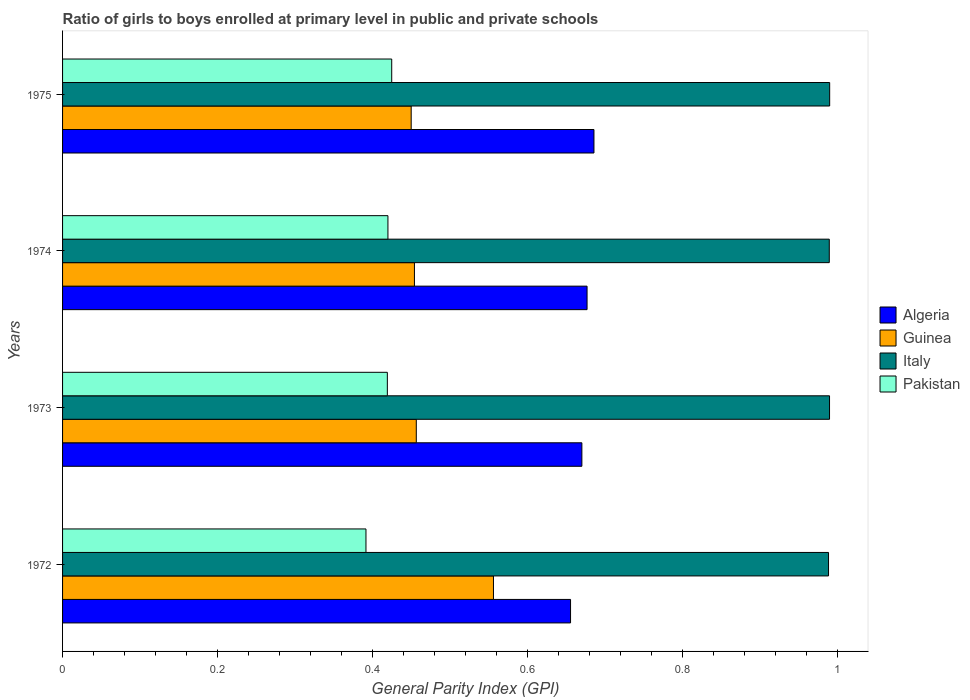What is the label of the 1st group of bars from the top?
Your answer should be compact. 1975. What is the general parity index in Guinea in 1975?
Your answer should be compact. 0.45. Across all years, what is the maximum general parity index in Pakistan?
Offer a very short reply. 0.42. Across all years, what is the minimum general parity index in Algeria?
Make the answer very short. 0.66. In which year was the general parity index in Pakistan maximum?
Give a very brief answer. 1975. What is the total general parity index in Italy in the graph?
Keep it short and to the point. 3.96. What is the difference between the general parity index in Pakistan in 1972 and that in 1974?
Offer a very short reply. -0.03. What is the difference between the general parity index in Guinea in 1973 and the general parity index in Italy in 1972?
Provide a short and direct response. -0.53. What is the average general parity index in Pakistan per year?
Provide a short and direct response. 0.41. In the year 1975, what is the difference between the general parity index in Guinea and general parity index in Algeria?
Ensure brevity in your answer.  -0.24. In how many years, is the general parity index in Algeria greater than 0.04 ?
Keep it short and to the point. 4. What is the ratio of the general parity index in Pakistan in 1973 to that in 1974?
Offer a very short reply. 1. Is the general parity index in Italy in 1973 less than that in 1975?
Keep it short and to the point. Yes. What is the difference between the highest and the second highest general parity index in Italy?
Provide a succinct answer. 0. What is the difference between the highest and the lowest general parity index in Pakistan?
Give a very brief answer. 0.03. In how many years, is the general parity index in Algeria greater than the average general parity index in Algeria taken over all years?
Your answer should be very brief. 2. Is the sum of the general parity index in Guinea in 1973 and 1975 greater than the maximum general parity index in Algeria across all years?
Your answer should be compact. Yes. Is it the case that in every year, the sum of the general parity index in Pakistan and general parity index in Italy is greater than the general parity index in Guinea?
Provide a succinct answer. Yes. What is the difference between two consecutive major ticks on the X-axis?
Your response must be concise. 0.2. Where does the legend appear in the graph?
Your answer should be compact. Center right. How many legend labels are there?
Provide a short and direct response. 4. What is the title of the graph?
Your answer should be very brief. Ratio of girls to boys enrolled at primary level in public and private schools. What is the label or title of the X-axis?
Your answer should be compact. General Parity Index (GPI). What is the General Parity Index (GPI) of Algeria in 1972?
Provide a short and direct response. 0.66. What is the General Parity Index (GPI) in Guinea in 1972?
Your response must be concise. 0.56. What is the General Parity Index (GPI) of Italy in 1972?
Give a very brief answer. 0.99. What is the General Parity Index (GPI) in Pakistan in 1972?
Provide a succinct answer. 0.39. What is the General Parity Index (GPI) of Algeria in 1973?
Offer a terse response. 0.67. What is the General Parity Index (GPI) in Guinea in 1973?
Your answer should be very brief. 0.46. What is the General Parity Index (GPI) in Italy in 1973?
Your response must be concise. 0.99. What is the General Parity Index (GPI) of Pakistan in 1973?
Give a very brief answer. 0.42. What is the General Parity Index (GPI) of Algeria in 1974?
Ensure brevity in your answer.  0.68. What is the General Parity Index (GPI) in Guinea in 1974?
Offer a very short reply. 0.45. What is the General Parity Index (GPI) of Italy in 1974?
Provide a succinct answer. 0.99. What is the General Parity Index (GPI) of Pakistan in 1974?
Ensure brevity in your answer.  0.42. What is the General Parity Index (GPI) in Algeria in 1975?
Offer a terse response. 0.69. What is the General Parity Index (GPI) in Guinea in 1975?
Your response must be concise. 0.45. What is the General Parity Index (GPI) of Italy in 1975?
Give a very brief answer. 0.99. What is the General Parity Index (GPI) in Pakistan in 1975?
Keep it short and to the point. 0.42. Across all years, what is the maximum General Parity Index (GPI) in Algeria?
Your answer should be compact. 0.69. Across all years, what is the maximum General Parity Index (GPI) in Guinea?
Provide a short and direct response. 0.56. Across all years, what is the maximum General Parity Index (GPI) in Italy?
Make the answer very short. 0.99. Across all years, what is the maximum General Parity Index (GPI) of Pakistan?
Make the answer very short. 0.42. Across all years, what is the minimum General Parity Index (GPI) in Algeria?
Offer a terse response. 0.66. Across all years, what is the minimum General Parity Index (GPI) in Guinea?
Your answer should be compact. 0.45. Across all years, what is the minimum General Parity Index (GPI) of Italy?
Provide a succinct answer. 0.99. Across all years, what is the minimum General Parity Index (GPI) in Pakistan?
Make the answer very short. 0.39. What is the total General Parity Index (GPI) in Algeria in the graph?
Offer a terse response. 2.69. What is the total General Parity Index (GPI) of Guinea in the graph?
Your answer should be very brief. 1.92. What is the total General Parity Index (GPI) of Italy in the graph?
Give a very brief answer. 3.96. What is the total General Parity Index (GPI) of Pakistan in the graph?
Make the answer very short. 1.65. What is the difference between the General Parity Index (GPI) in Algeria in 1972 and that in 1973?
Your answer should be very brief. -0.01. What is the difference between the General Parity Index (GPI) of Guinea in 1972 and that in 1973?
Provide a succinct answer. 0.1. What is the difference between the General Parity Index (GPI) in Italy in 1972 and that in 1973?
Provide a succinct answer. -0. What is the difference between the General Parity Index (GPI) of Pakistan in 1972 and that in 1973?
Provide a succinct answer. -0.03. What is the difference between the General Parity Index (GPI) in Algeria in 1972 and that in 1974?
Your answer should be very brief. -0.02. What is the difference between the General Parity Index (GPI) of Guinea in 1972 and that in 1974?
Your answer should be compact. 0.1. What is the difference between the General Parity Index (GPI) in Italy in 1972 and that in 1974?
Your answer should be very brief. -0. What is the difference between the General Parity Index (GPI) in Pakistan in 1972 and that in 1974?
Offer a terse response. -0.03. What is the difference between the General Parity Index (GPI) in Algeria in 1972 and that in 1975?
Your answer should be compact. -0.03. What is the difference between the General Parity Index (GPI) of Guinea in 1972 and that in 1975?
Give a very brief answer. 0.11. What is the difference between the General Parity Index (GPI) in Italy in 1972 and that in 1975?
Keep it short and to the point. -0. What is the difference between the General Parity Index (GPI) in Pakistan in 1972 and that in 1975?
Give a very brief answer. -0.03. What is the difference between the General Parity Index (GPI) in Algeria in 1973 and that in 1974?
Ensure brevity in your answer.  -0.01. What is the difference between the General Parity Index (GPI) in Guinea in 1973 and that in 1974?
Offer a terse response. 0. What is the difference between the General Parity Index (GPI) of Italy in 1973 and that in 1974?
Your answer should be very brief. 0. What is the difference between the General Parity Index (GPI) in Pakistan in 1973 and that in 1974?
Offer a very short reply. -0. What is the difference between the General Parity Index (GPI) of Algeria in 1973 and that in 1975?
Ensure brevity in your answer.  -0.02. What is the difference between the General Parity Index (GPI) of Guinea in 1973 and that in 1975?
Your answer should be very brief. 0.01. What is the difference between the General Parity Index (GPI) in Italy in 1973 and that in 1975?
Give a very brief answer. -0. What is the difference between the General Parity Index (GPI) in Pakistan in 1973 and that in 1975?
Keep it short and to the point. -0.01. What is the difference between the General Parity Index (GPI) in Algeria in 1974 and that in 1975?
Ensure brevity in your answer.  -0.01. What is the difference between the General Parity Index (GPI) of Guinea in 1974 and that in 1975?
Your response must be concise. 0. What is the difference between the General Parity Index (GPI) in Italy in 1974 and that in 1975?
Provide a short and direct response. -0. What is the difference between the General Parity Index (GPI) of Pakistan in 1974 and that in 1975?
Give a very brief answer. -0. What is the difference between the General Parity Index (GPI) in Algeria in 1972 and the General Parity Index (GPI) in Guinea in 1973?
Offer a very short reply. 0.2. What is the difference between the General Parity Index (GPI) of Algeria in 1972 and the General Parity Index (GPI) of Italy in 1973?
Give a very brief answer. -0.33. What is the difference between the General Parity Index (GPI) of Algeria in 1972 and the General Parity Index (GPI) of Pakistan in 1973?
Ensure brevity in your answer.  0.24. What is the difference between the General Parity Index (GPI) of Guinea in 1972 and the General Parity Index (GPI) of Italy in 1973?
Make the answer very short. -0.43. What is the difference between the General Parity Index (GPI) of Guinea in 1972 and the General Parity Index (GPI) of Pakistan in 1973?
Your response must be concise. 0.14. What is the difference between the General Parity Index (GPI) in Italy in 1972 and the General Parity Index (GPI) in Pakistan in 1973?
Ensure brevity in your answer.  0.57. What is the difference between the General Parity Index (GPI) in Algeria in 1972 and the General Parity Index (GPI) in Guinea in 1974?
Make the answer very short. 0.2. What is the difference between the General Parity Index (GPI) in Algeria in 1972 and the General Parity Index (GPI) in Italy in 1974?
Offer a very short reply. -0.33. What is the difference between the General Parity Index (GPI) in Algeria in 1972 and the General Parity Index (GPI) in Pakistan in 1974?
Your answer should be very brief. 0.24. What is the difference between the General Parity Index (GPI) of Guinea in 1972 and the General Parity Index (GPI) of Italy in 1974?
Your answer should be compact. -0.43. What is the difference between the General Parity Index (GPI) in Guinea in 1972 and the General Parity Index (GPI) in Pakistan in 1974?
Keep it short and to the point. 0.14. What is the difference between the General Parity Index (GPI) of Italy in 1972 and the General Parity Index (GPI) of Pakistan in 1974?
Ensure brevity in your answer.  0.57. What is the difference between the General Parity Index (GPI) of Algeria in 1972 and the General Parity Index (GPI) of Guinea in 1975?
Give a very brief answer. 0.21. What is the difference between the General Parity Index (GPI) in Algeria in 1972 and the General Parity Index (GPI) in Italy in 1975?
Provide a short and direct response. -0.33. What is the difference between the General Parity Index (GPI) of Algeria in 1972 and the General Parity Index (GPI) of Pakistan in 1975?
Offer a very short reply. 0.23. What is the difference between the General Parity Index (GPI) in Guinea in 1972 and the General Parity Index (GPI) in Italy in 1975?
Offer a very short reply. -0.43. What is the difference between the General Parity Index (GPI) in Guinea in 1972 and the General Parity Index (GPI) in Pakistan in 1975?
Offer a very short reply. 0.13. What is the difference between the General Parity Index (GPI) of Italy in 1972 and the General Parity Index (GPI) of Pakistan in 1975?
Offer a terse response. 0.56. What is the difference between the General Parity Index (GPI) of Algeria in 1973 and the General Parity Index (GPI) of Guinea in 1974?
Offer a very short reply. 0.22. What is the difference between the General Parity Index (GPI) in Algeria in 1973 and the General Parity Index (GPI) in Italy in 1974?
Your answer should be compact. -0.32. What is the difference between the General Parity Index (GPI) in Algeria in 1973 and the General Parity Index (GPI) in Pakistan in 1974?
Offer a terse response. 0.25. What is the difference between the General Parity Index (GPI) of Guinea in 1973 and the General Parity Index (GPI) of Italy in 1974?
Provide a succinct answer. -0.53. What is the difference between the General Parity Index (GPI) in Guinea in 1973 and the General Parity Index (GPI) in Pakistan in 1974?
Your answer should be compact. 0.04. What is the difference between the General Parity Index (GPI) in Italy in 1973 and the General Parity Index (GPI) in Pakistan in 1974?
Your answer should be very brief. 0.57. What is the difference between the General Parity Index (GPI) in Algeria in 1973 and the General Parity Index (GPI) in Guinea in 1975?
Keep it short and to the point. 0.22. What is the difference between the General Parity Index (GPI) in Algeria in 1973 and the General Parity Index (GPI) in Italy in 1975?
Your response must be concise. -0.32. What is the difference between the General Parity Index (GPI) in Algeria in 1973 and the General Parity Index (GPI) in Pakistan in 1975?
Offer a terse response. 0.25. What is the difference between the General Parity Index (GPI) in Guinea in 1973 and the General Parity Index (GPI) in Italy in 1975?
Your answer should be compact. -0.53. What is the difference between the General Parity Index (GPI) of Guinea in 1973 and the General Parity Index (GPI) of Pakistan in 1975?
Offer a terse response. 0.03. What is the difference between the General Parity Index (GPI) of Italy in 1973 and the General Parity Index (GPI) of Pakistan in 1975?
Ensure brevity in your answer.  0.56. What is the difference between the General Parity Index (GPI) in Algeria in 1974 and the General Parity Index (GPI) in Guinea in 1975?
Make the answer very short. 0.23. What is the difference between the General Parity Index (GPI) of Algeria in 1974 and the General Parity Index (GPI) of Italy in 1975?
Provide a short and direct response. -0.31. What is the difference between the General Parity Index (GPI) of Algeria in 1974 and the General Parity Index (GPI) of Pakistan in 1975?
Provide a succinct answer. 0.25. What is the difference between the General Parity Index (GPI) of Guinea in 1974 and the General Parity Index (GPI) of Italy in 1975?
Give a very brief answer. -0.54. What is the difference between the General Parity Index (GPI) in Guinea in 1974 and the General Parity Index (GPI) in Pakistan in 1975?
Keep it short and to the point. 0.03. What is the difference between the General Parity Index (GPI) of Italy in 1974 and the General Parity Index (GPI) of Pakistan in 1975?
Give a very brief answer. 0.56. What is the average General Parity Index (GPI) in Algeria per year?
Offer a terse response. 0.67. What is the average General Parity Index (GPI) in Guinea per year?
Offer a terse response. 0.48. What is the average General Parity Index (GPI) of Italy per year?
Offer a terse response. 0.99. What is the average General Parity Index (GPI) of Pakistan per year?
Make the answer very short. 0.41. In the year 1972, what is the difference between the General Parity Index (GPI) in Algeria and General Parity Index (GPI) in Guinea?
Provide a short and direct response. 0.1. In the year 1972, what is the difference between the General Parity Index (GPI) in Algeria and General Parity Index (GPI) in Italy?
Give a very brief answer. -0.33. In the year 1972, what is the difference between the General Parity Index (GPI) in Algeria and General Parity Index (GPI) in Pakistan?
Provide a succinct answer. 0.26. In the year 1972, what is the difference between the General Parity Index (GPI) of Guinea and General Parity Index (GPI) of Italy?
Keep it short and to the point. -0.43. In the year 1972, what is the difference between the General Parity Index (GPI) in Guinea and General Parity Index (GPI) in Pakistan?
Make the answer very short. 0.16. In the year 1972, what is the difference between the General Parity Index (GPI) of Italy and General Parity Index (GPI) of Pakistan?
Give a very brief answer. 0.6. In the year 1973, what is the difference between the General Parity Index (GPI) of Algeria and General Parity Index (GPI) of Guinea?
Provide a succinct answer. 0.21. In the year 1973, what is the difference between the General Parity Index (GPI) of Algeria and General Parity Index (GPI) of Italy?
Provide a short and direct response. -0.32. In the year 1973, what is the difference between the General Parity Index (GPI) in Algeria and General Parity Index (GPI) in Pakistan?
Make the answer very short. 0.25. In the year 1973, what is the difference between the General Parity Index (GPI) of Guinea and General Parity Index (GPI) of Italy?
Make the answer very short. -0.53. In the year 1973, what is the difference between the General Parity Index (GPI) in Guinea and General Parity Index (GPI) in Pakistan?
Offer a terse response. 0.04. In the year 1973, what is the difference between the General Parity Index (GPI) in Italy and General Parity Index (GPI) in Pakistan?
Make the answer very short. 0.57. In the year 1974, what is the difference between the General Parity Index (GPI) in Algeria and General Parity Index (GPI) in Guinea?
Ensure brevity in your answer.  0.22. In the year 1974, what is the difference between the General Parity Index (GPI) of Algeria and General Parity Index (GPI) of Italy?
Make the answer very short. -0.31. In the year 1974, what is the difference between the General Parity Index (GPI) of Algeria and General Parity Index (GPI) of Pakistan?
Your response must be concise. 0.26. In the year 1974, what is the difference between the General Parity Index (GPI) of Guinea and General Parity Index (GPI) of Italy?
Your answer should be very brief. -0.54. In the year 1974, what is the difference between the General Parity Index (GPI) of Guinea and General Parity Index (GPI) of Pakistan?
Offer a terse response. 0.03. In the year 1974, what is the difference between the General Parity Index (GPI) of Italy and General Parity Index (GPI) of Pakistan?
Keep it short and to the point. 0.57. In the year 1975, what is the difference between the General Parity Index (GPI) in Algeria and General Parity Index (GPI) in Guinea?
Provide a succinct answer. 0.24. In the year 1975, what is the difference between the General Parity Index (GPI) of Algeria and General Parity Index (GPI) of Italy?
Ensure brevity in your answer.  -0.3. In the year 1975, what is the difference between the General Parity Index (GPI) of Algeria and General Parity Index (GPI) of Pakistan?
Your answer should be compact. 0.26. In the year 1975, what is the difference between the General Parity Index (GPI) of Guinea and General Parity Index (GPI) of Italy?
Ensure brevity in your answer.  -0.54. In the year 1975, what is the difference between the General Parity Index (GPI) in Guinea and General Parity Index (GPI) in Pakistan?
Provide a succinct answer. 0.03. In the year 1975, what is the difference between the General Parity Index (GPI) in Italy and General Parity Index (GPI) in Pakistan?
Provide a succinct answer. 0.56. What is the ratio of the General Parity Index (GPI) of Algeria in 1972 to that in 1973?
Ensure brevity in your answer.  0.98. What is the ratio of the General Parity Index (GPI) of Guinea in 1972 to that in 1973?
Ensure brevity in your answer.  1.22. What is the ratio of the General Parity Index (GPI) of Pakistan in 1972 to that in 1973?
Provide a succinct answer. 0.93. What is the ratio of the General Parity Index (GPI) in Algeria in 1972 to that in 1974?
Provide a short and direct response. 0.97. What is the ratio of the General Parity Index (GPI) of Guinea in 1972 to that in 1974?
Your response must be concise. 1.22. What is the ratio of the General Parity Index (GPI) of Italy in 1972 to that in 1974?
Offer a terse response. 1. What is the ratio of the General Parity Index (GPI) of Pakistan in 1972 to that in 1974?
Give a very brief answer. 0.93. What is the ratio of the General Parity Index (GPI) of Algeria in 1972 to that in 1975?
Make the answer very short. 0.96. What is the ratio of the General Parity Index (GPI) of Guinea in 1972 to that in 1975?
Your answer should be compact. 1.24. What is the ratio of the General Parity Index (GPI) in Pakistan in 1972 to that in 1975?
Provide a short and direct response. 0.92. What is the ratio of the General Parity Index (GPI) in Algeria in 1973 to that in 1974?
Offer a terse response. 0.99. What is the ratio of the General Parity Index (GPI) of Guinea in 1973 to that in 1974?
Ensure brevity in your answer.  1.01. What is the ratio of the General Parity Index (GPI) in Pakistan in 1973 to that in 1974?
Provide a short and direct response. 1. What is the ratio of the General Parity Index (GPI) in Algeria in 1973 to that in 1975?
Make the answer very short. 0.98. What is the ratio of the General Parity Index (GPI) in Guinea in 1973 to that in 1975?
Your answer should be compact. 1.01. What is the ratio of the General Parity Index (GPI) of Italy in 1973 to that in 1975?
Keep it short and to the point. 1. What is the ratio of the General Parity Index (GPI) of Pakistan in 1973 to that in 1975?
Your answer should be compact. 0.99. What is the ratio of the General Parity Index (GPI) of Guinea in 1974 to that in 1975?
Offer a very short reply. 1.01. What is the ratio of the General Parity Index (GPI) of Pakistan in 1974 to that in 1975?
Your response must be concise. 0.99. What is the difference between the highest and the second highest General Parity Index (GPI) in Algeria?
Give a very brief answer. 0.01. What is the difference between the highest and the second highest General Parity Index (GPI) in Guinea?
Provide a short and direct response. 0.1. What is the difference between the highest and the second highest General Parity Index (GPI) of Pakistan?
Make the answer very short. 0. What is the difference between the highest and the lowest General Parity Index (GPI) of Algeria?
Your answer should be very brief. 0.03. What is the difference between the highest and the lowest General Parity Index (GPI) in Guinea?
Your response must be concise. 0.11. What is the difference between the highest and the lowest General Parity Index (GPI) in Italy?
Give a very brief answer. 0. What is the difference between the highest and the lowest General Parity Index (GPI) of Pakistan?
Your answer should be compact. 0.03. 